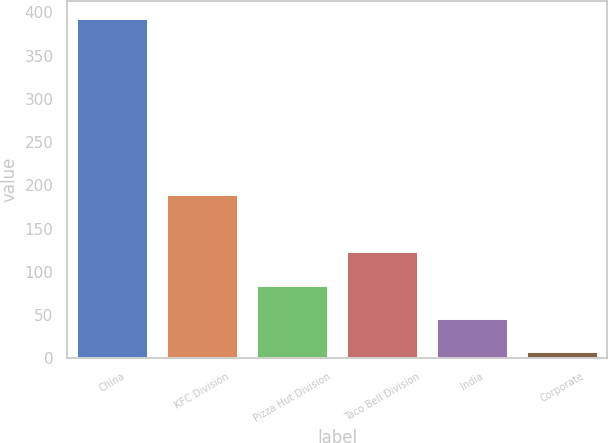<chart> <loc_0><loc_0><loc_500><loc_500><bar_chart><fcel>China<fcel>KFC Division<fcel>Pizza Hut Division<fcel>Taco Bell Division<fcel>India<fcel>Corporate<nl><fcel>394<fcel>190<fcel>85.2<fcel>123.8<fcel>46.6<fcel>8<nl></chart> 